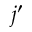<formula> <loc_0><loc_0><loc_500><loc_500>j ^ { \prime }</formula> 